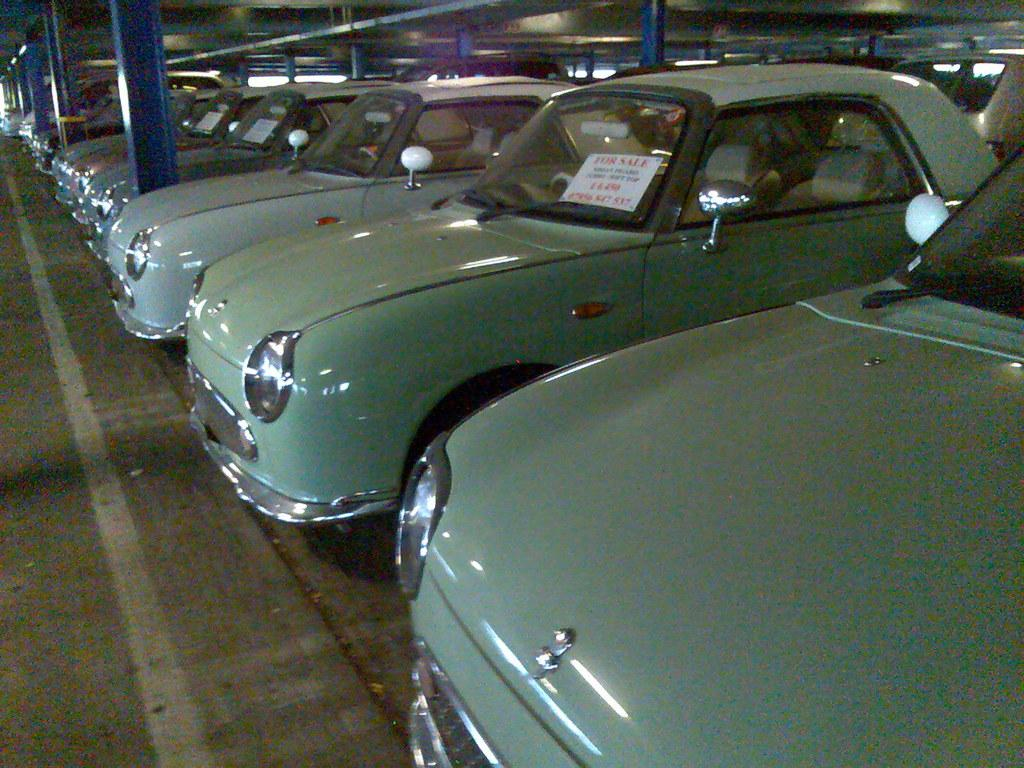What is the main subject of the image? The main subject of the image is many cars. What else can be seen in the image besides the cars? There are notices, pillars, and lights in the image. What information do the notices contain? The notices have text on them. What might be used to provide illumination in the image? There are lights in the image. How does the friction between the cars and the road affect the sound of the bells in the image? There are no bells present in the image, so the friction between the cars and the road does not affect the sound of any bells. 